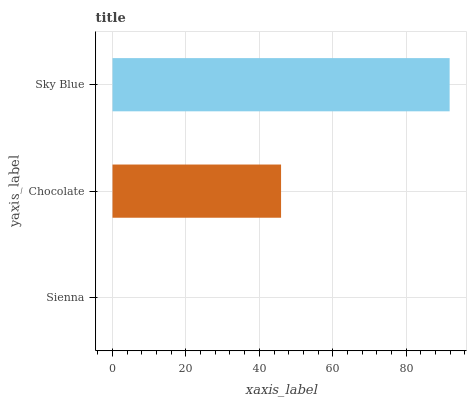Is Sienna the minimum?
Answer yes or no. Yes. Is Sky Blue the maximum?
Answer yes or no. Yes. Is Chocolate the minimum?
Answer yes or no. No. Is Chocolate the maximum?
Answer yes or no. No. Is Chocolate greater than Sienna?
Answer yes or no. Yes. Is Sienna less than Chocolate?
Answer yes or no. Yes. Is Sienna greater than Chocolate?
Answer yes or no. No. Is Chocolate less than Sienna?
Answer yes or no. No. Is Chocolate the high median?
Answer yes or no. Yes. Is Chocolate the low median?
Answer yes or no. Yes. Is Sky Blue the high median?
Answer yes or no. No. Is Sienna the low median?
Answer yes or no. No. 